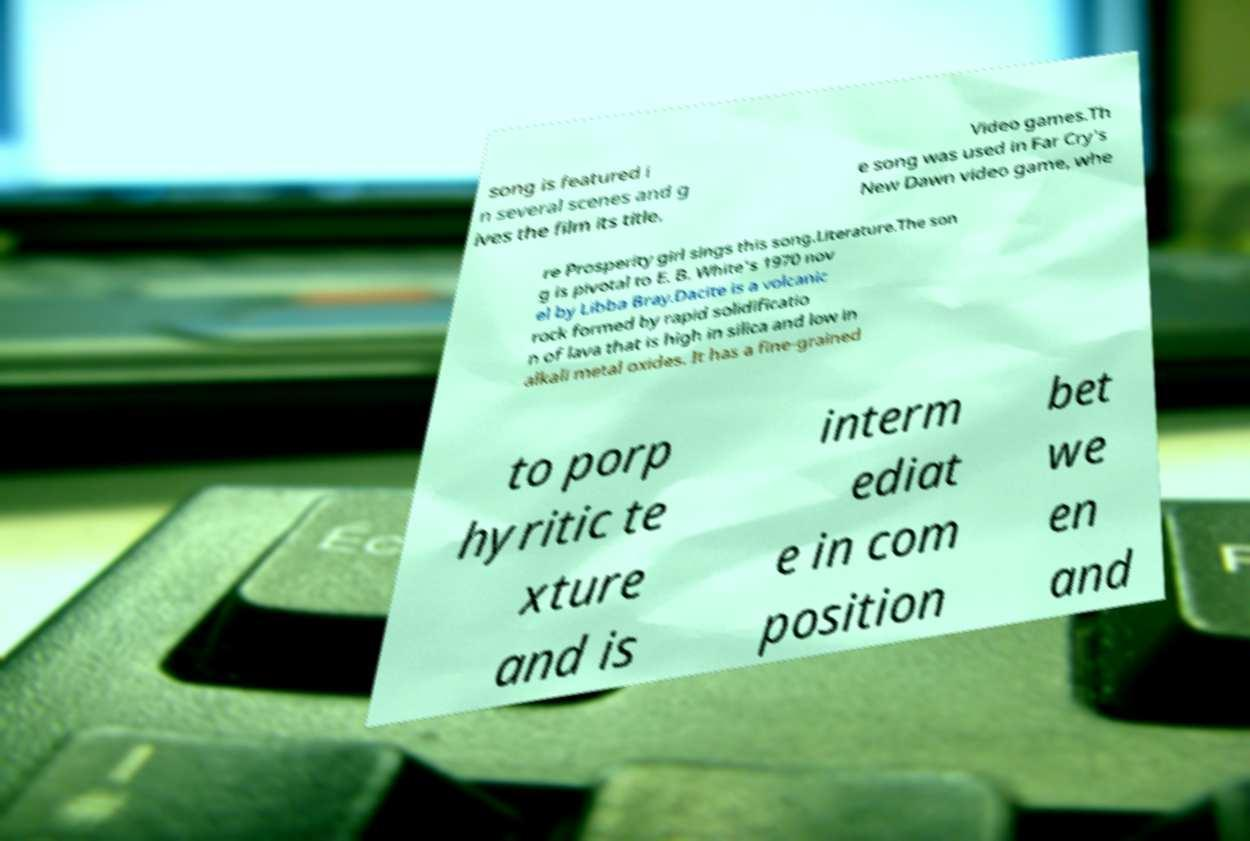Can you accurately transcribe the text from the provided image for me? song is featured i n several scenes and g ives the film its title. Video games.Th e song was used in Far Cry's New Dawn video game, whe re Prosperity girl sings this song.Literature.The son g is pivotal to E. B. White's 1970 nov el by Libba Bray.Dacite is a volcanic rock formed by rapid solidificatio n of lava that is high in silica and low in alkali metal oxides. It has a fine-grained to porp hyritic te xture and is interm ediat e in com position bet we en and 